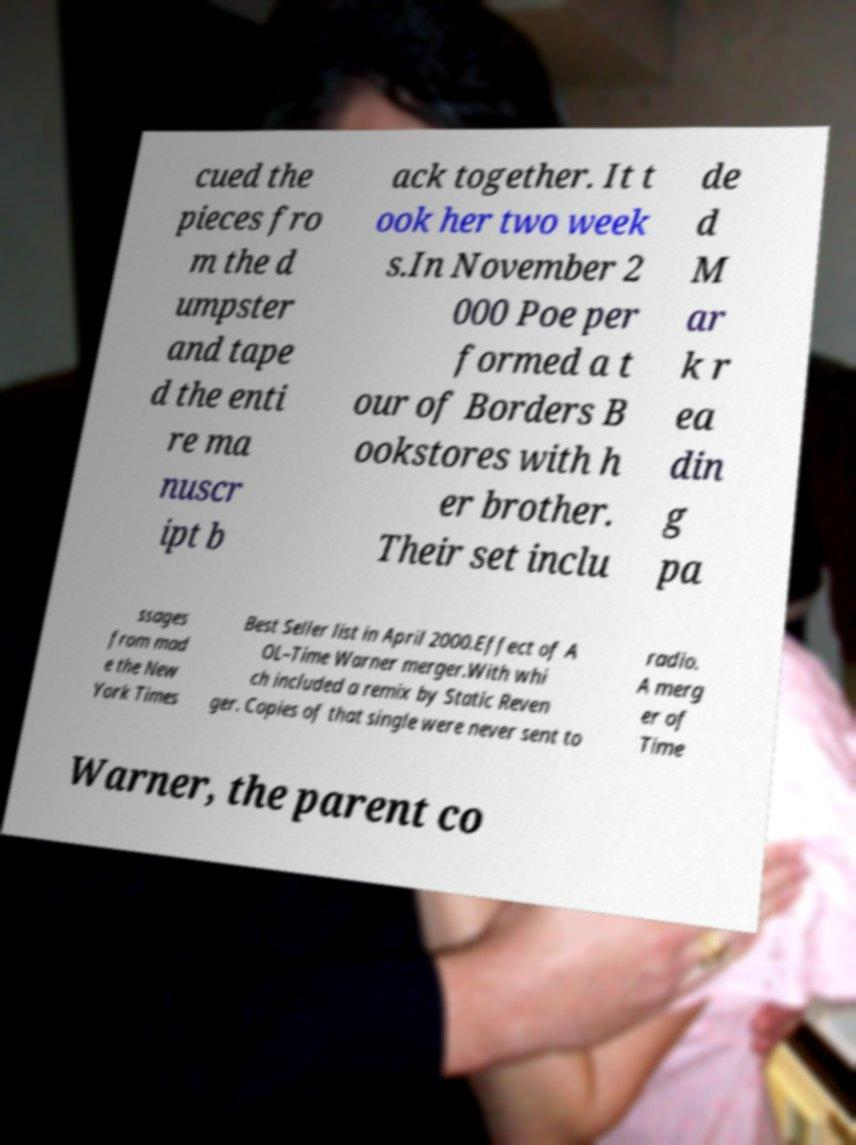Can you read and provide the text displayed in the image?This photo seems to have some interesting text. Can you extract and type it out for me? cued the pieces fro m the d umpster and tape d the enti re ma nuscr ipt b ack together. It t ook her two week s.In November 2 000 Poe per formed a t our of Borders B ookstores with h er brother. Their set inclu de d M ar k r ea din g pa ssages from mad e the New York Times Best Seller list in April 2000.Effect of A OL–Time Warner merger.With whi ch included a remix by Static Reven ger. Copies of that single were never sent to radio. A merg er of Time Warner, the parent co 